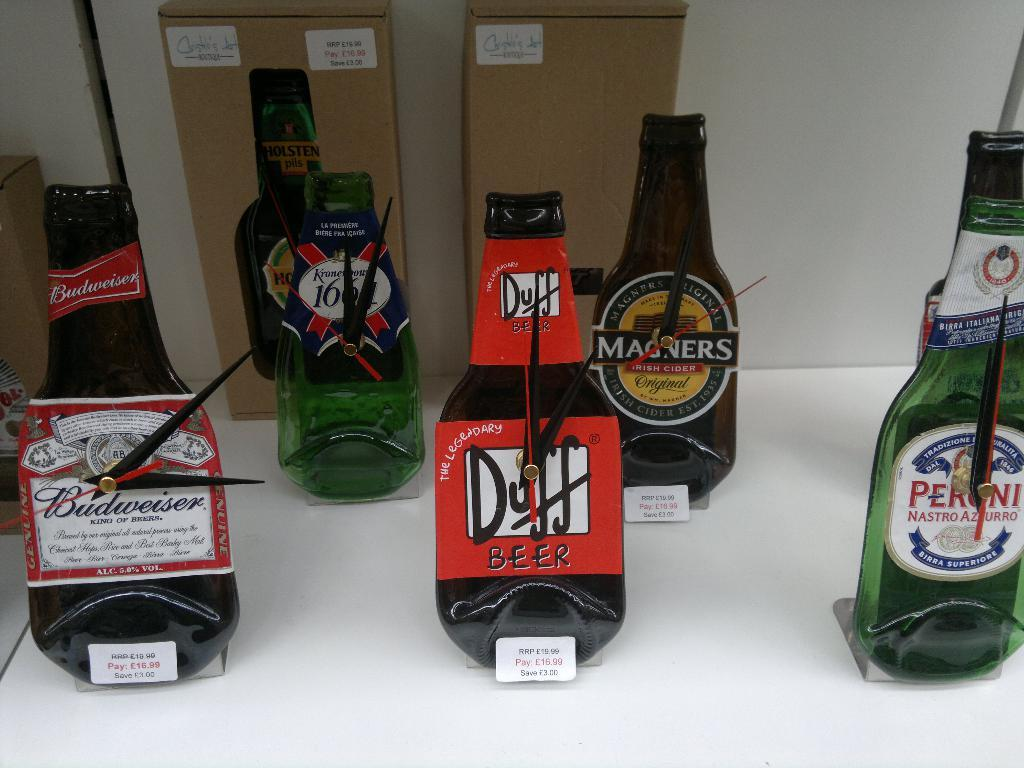<image>
Relay a brief, clear account of the picture shown. Bottles of beer are lined up together including Budweiser. 